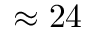Convert formula to latex. <formula><loc_0><loc_0><loc_500><loc_500>\approx 2 4</formula> 